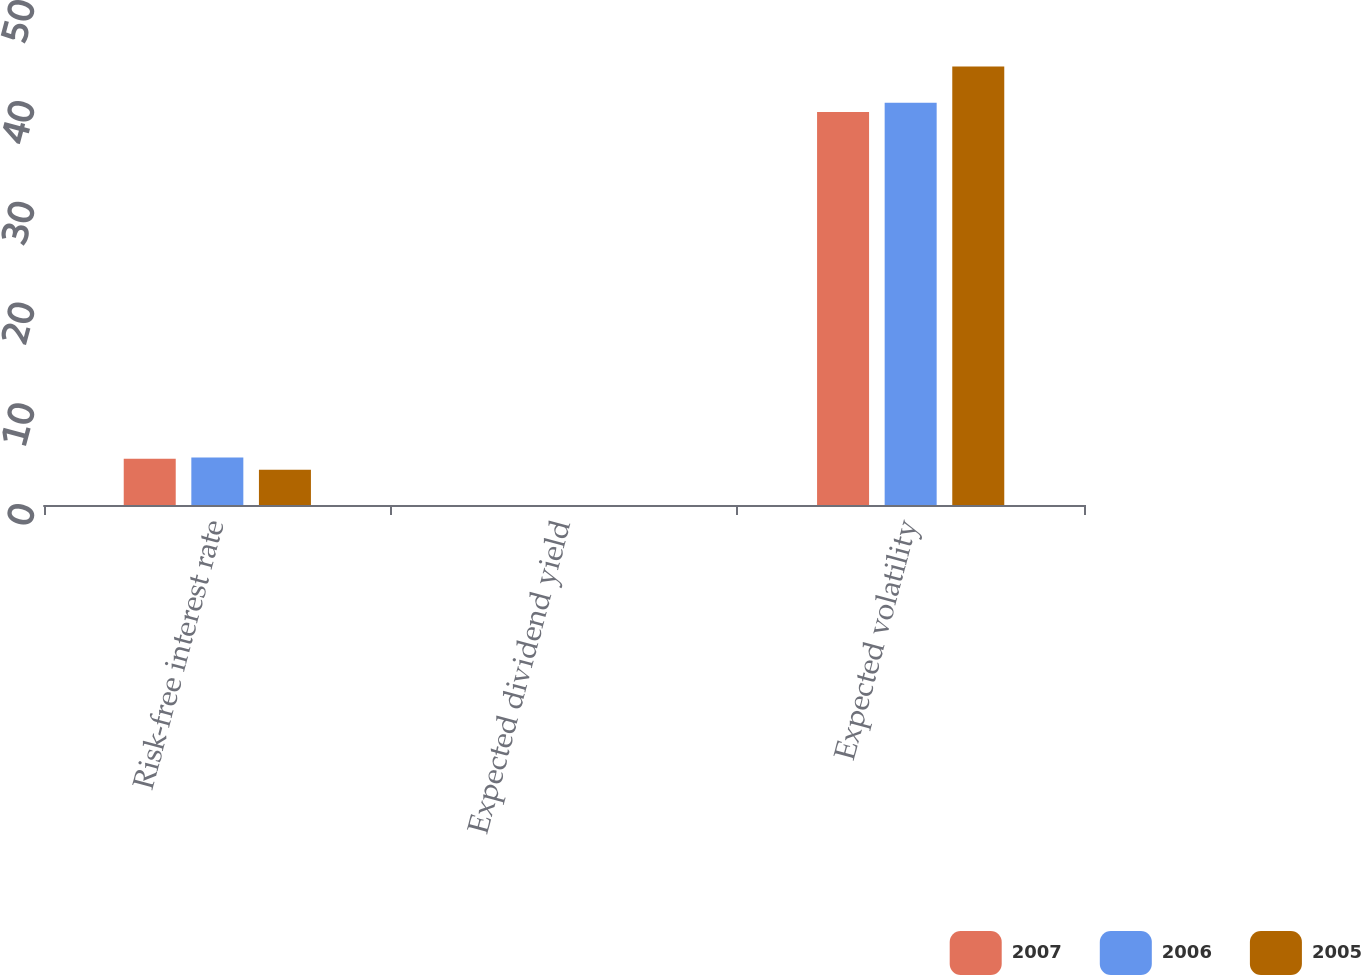<chart> <loc_0><loc_0><loc_500><loc_500><stacked_bar_chart><ecel><fcel>Risk-free interest rate<fcel>Expected dividend yield<fcel>Expected volatility<nl><fcel>2007<fcel>4.6<fcel>0<fcel>39<nl><fcel>2006<fcel>4.7<fcel>0<fcel>39.9<nl><fcel>2005<fcel>3.5<fcel>0<fcel>43.5<nl></chart> 